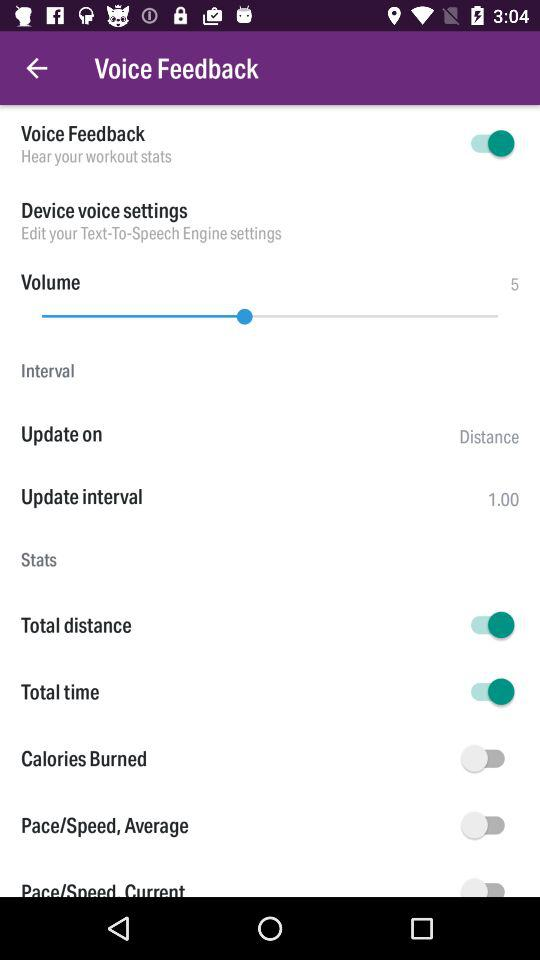What is the selected level of volume? The selected level of volume is 5. 